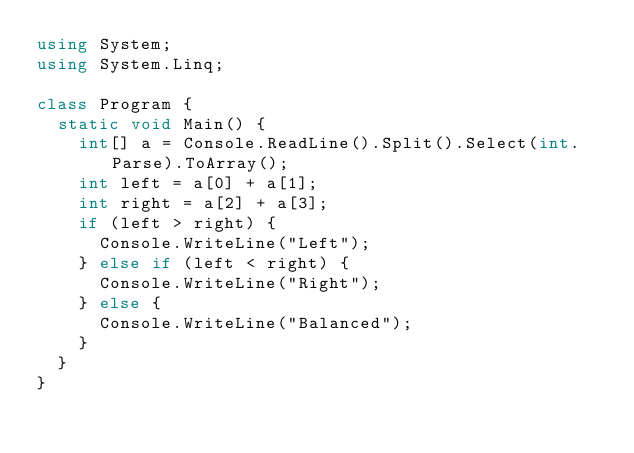<code> <loc_0><loc_0><loc_500><loc_500><_C#_>using System;
using System.Linq;

class Program {
  static void Main() {
    int[] a = Console.ReadLine().Split().Select(int.Parse).ToArray();
    int left = a[0] + a[1];
    int right = a[2] + a[3];
    if (left > right) {
      Console.WriteLine("Left");
    } else if (left < right) {
      Console.WriteLine("Right");
    } else {
      Console.WriteLine("Balanced");
    }
  }
}</code> 